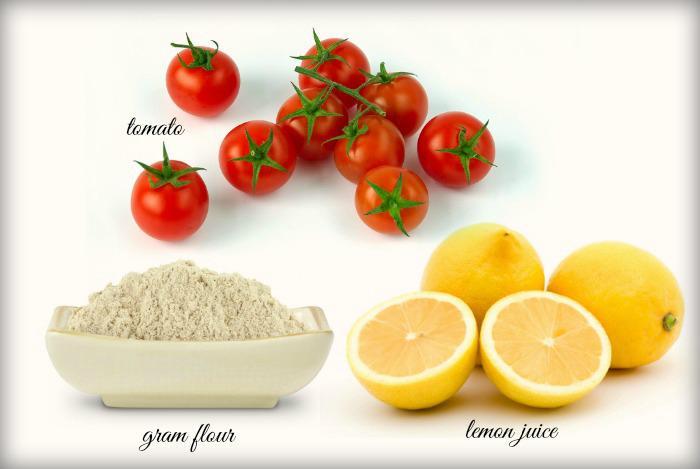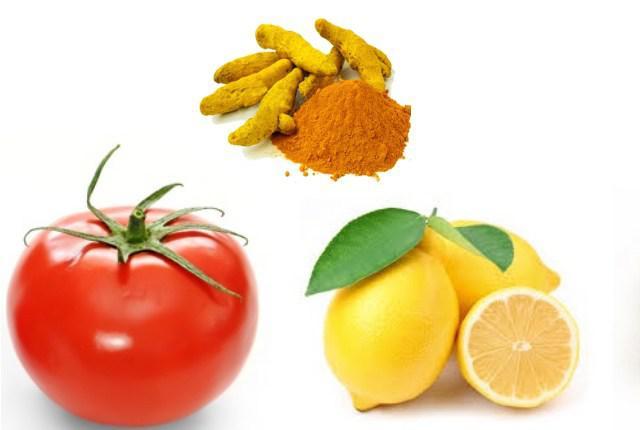The first image is the image on the left, the second image is the image on the right. For the images displayed, is the sentence "There is a whole un cut tomato next to lemon and whole turmeric root which is next to the powdered turmeric" factually correct? Answer yes or no. Yes. The first image is the image on the left, the second image is the image on the right. Examine the images to the left and right. Is the description "The left image includes at least one whole tomato and whole lemon, and exactly one bowl of grain." accurate? Answer yes or no. Yes. 